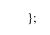Convert code to text. <code><loc_0><loc_0><loc_500><loc_500><_JavaScript_>};
</code> 